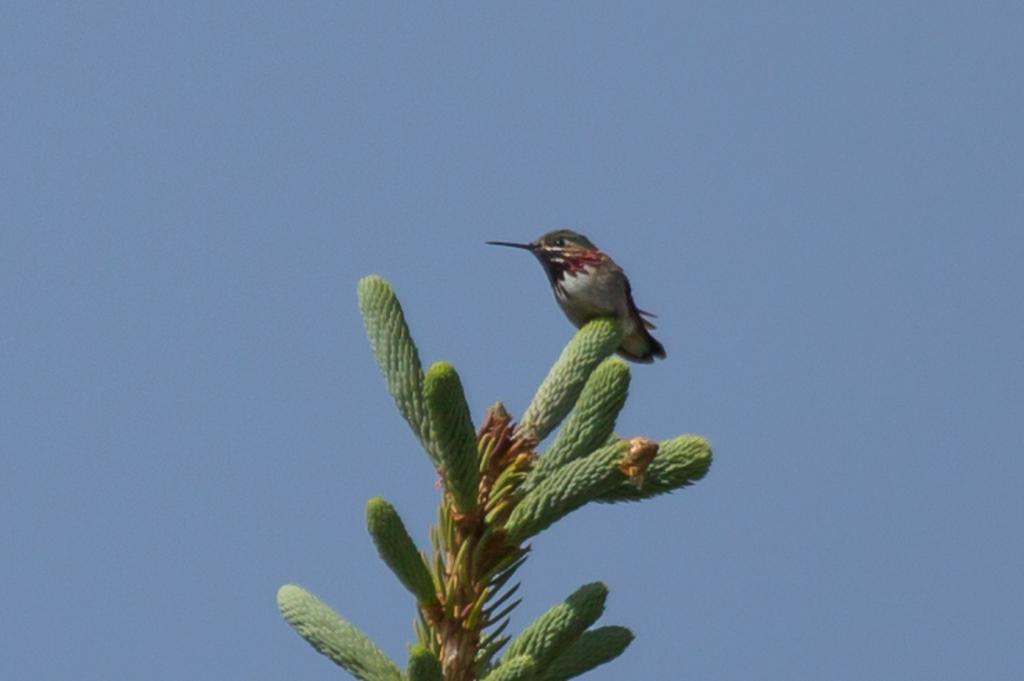What type of living organism can be seen in the image? There is a plant in the image. What animal is on the plant? A bird is present on the plant. What can be seen in the background of the image? The sky is visible in the background of the image. What type of letter is being delivered by the bird in the image? There is no letter present in the image, and the bird is not delivering anything. 